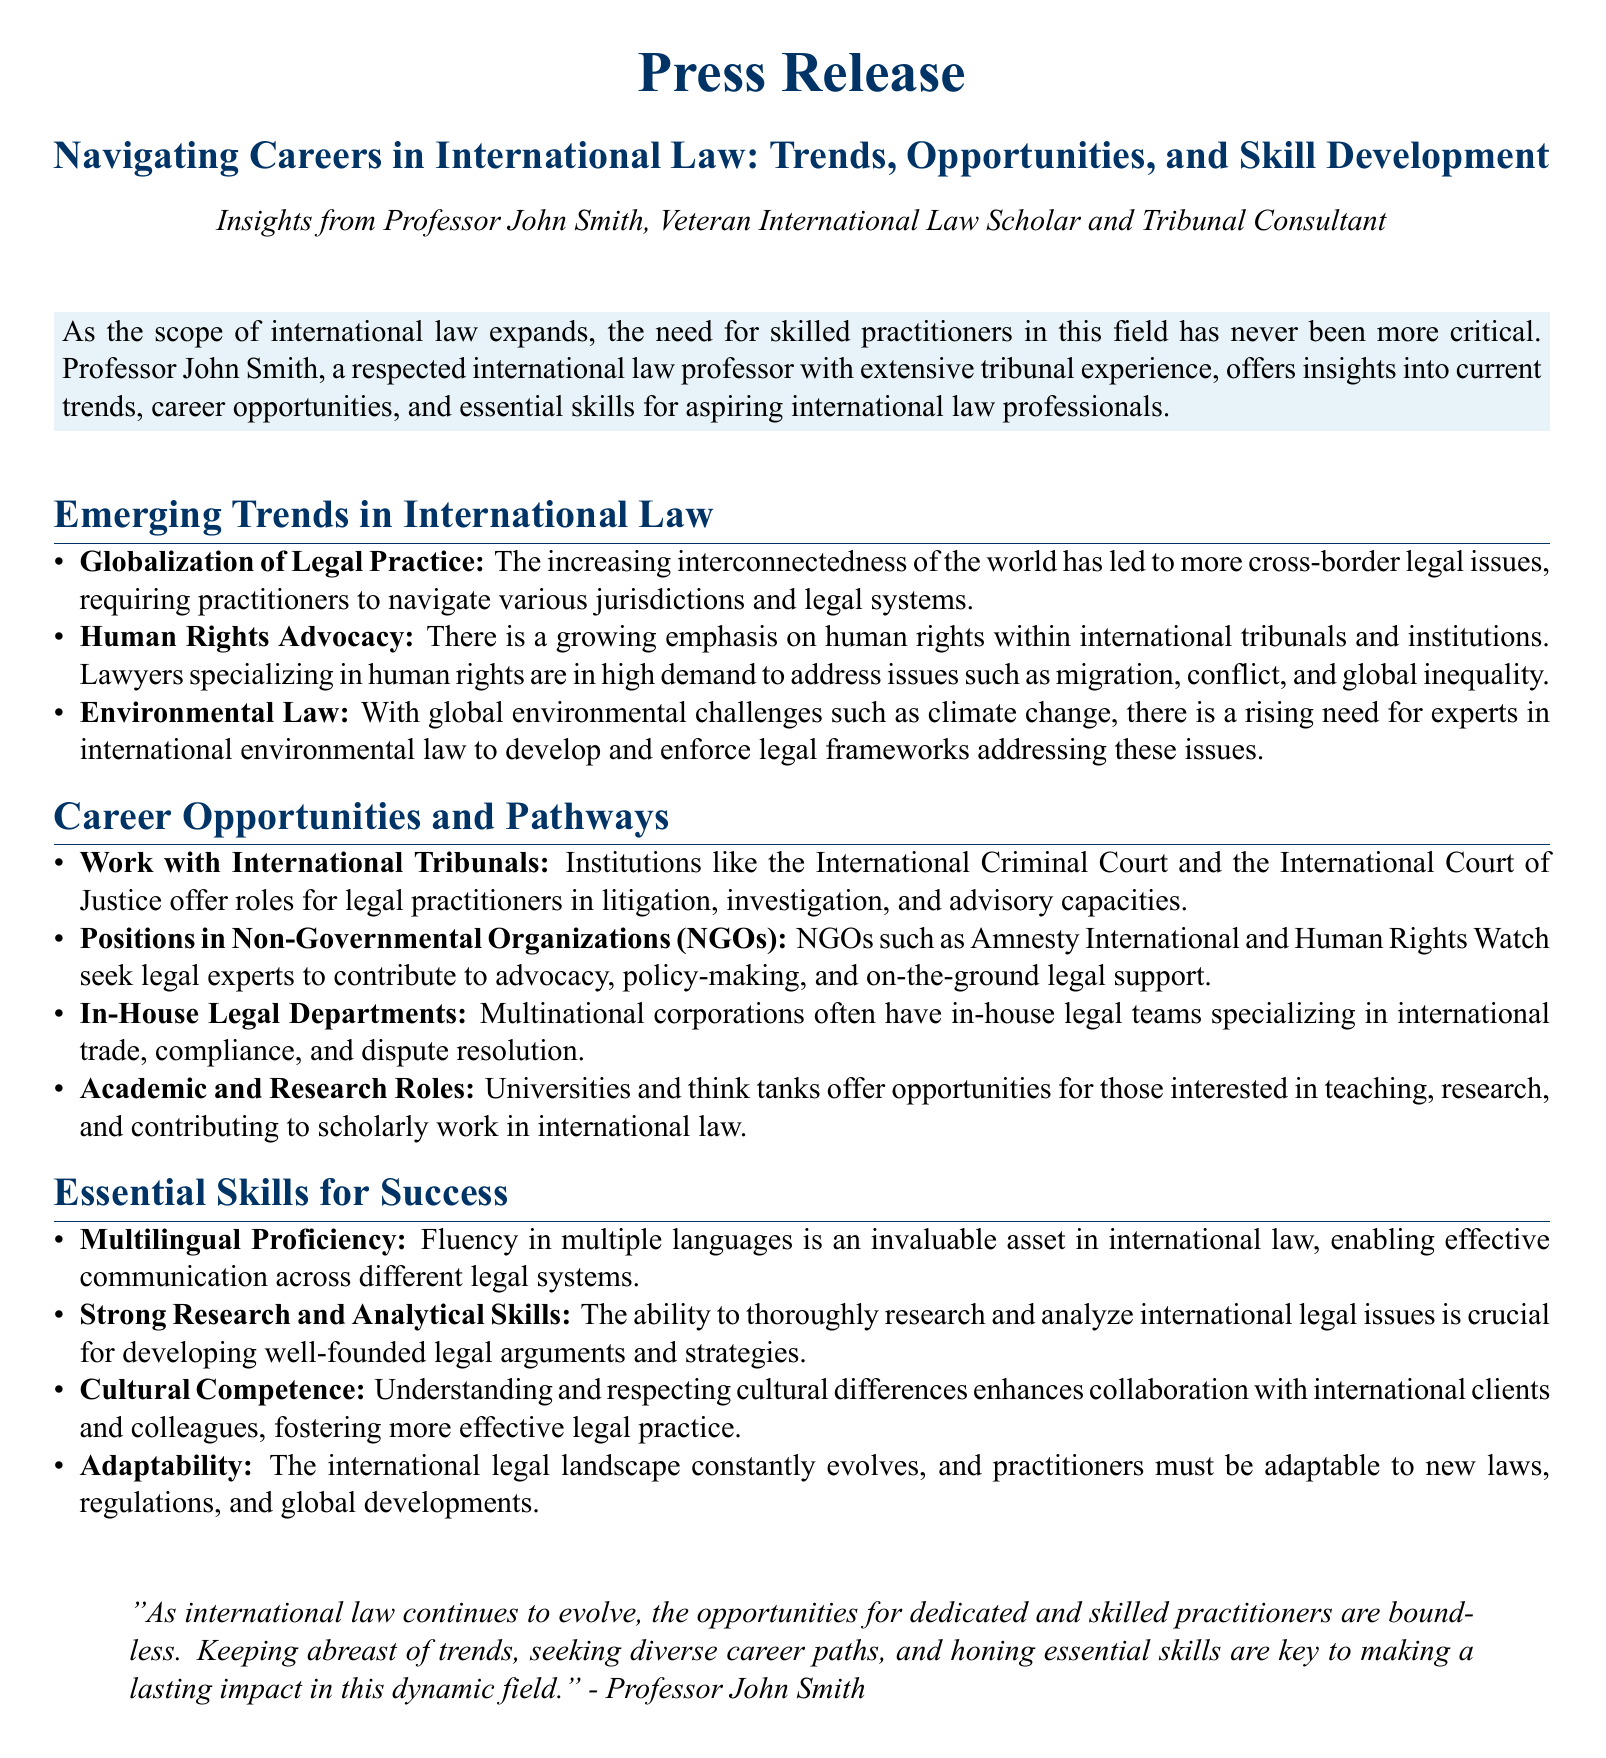What are the emerging trends in international law? The document lists three key trends: globalization of legal practice, human rights advocacy, and environmental law.
Answer: Globalization of legal practice, human rights advocacy, environmental law Who provides insights in the press release? The press release features insights from Professor John Smith, a veteran in international law.
Answer: Professor John Smith What is one career opportunity mentioned for international law practitioners? The document outlines multiple career opportunities, one of which includes working with international tribunals.
Answer: Work with international tribunals What essential skill is highlighted for success in international law? The press release emphasizes several skills; one is multilingual proficiency.
Answer: Multilingual proficiency Which organizations seek legal experts according to the document? The press release mentions NGOs like Amnesty International and Human Rights Watch as seeking legal experts.
Answer: Amnesty International, Human Rights Watch What is a critical quality for international law practitioners? The press release identifies adaptability as a critical quality necessary for practitioners in this changing field.
Answer: Adaptability What type of document is this? This document is a press release, a type specifically designed to convey information to the public.
Answer: Press release 